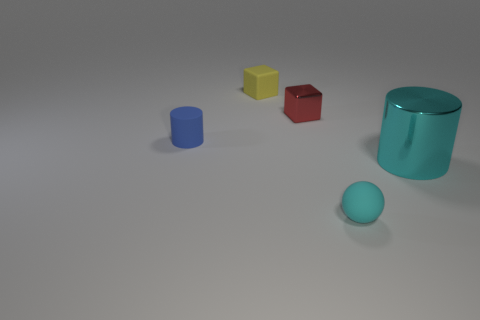Is there anything else that has the same size as the shiny cylinder?
Keep it short and to the point. No. There is a thing to the left of the yellow object; what number of tiny matte objects are on the right side of it?
Give a very brief answer. 2. Are there any blue objects in front of the cyan thing that is in front of the shiny cylinder?
Your response must be concise. No. There is a big cylinder; are there any blue matte objects in front of it?
Offer a terse response. No. There is a cyan object to the left of the big cylinder; does it have the same shape as the red object?
Ensure brevity in your answer.  No. What number of tiny red shiny things are the same shape as the small yellow matte thing?
Ensure brevity in your answer.  1. Is there a purple block that has the same material as the yellow cube?
Provide a short and direct response. No. There is a cylinder right of the metallic thing that is to the left of the tiny cyan object; what is its material?
Keep it short and to the point. Metal. What size is the matte object behind the tiny red thing?
Offer a very short reply. Small. There is a small sphere; is it the same color as the metallic thing to the left of the big thing?
Offer a very short reply. No. 